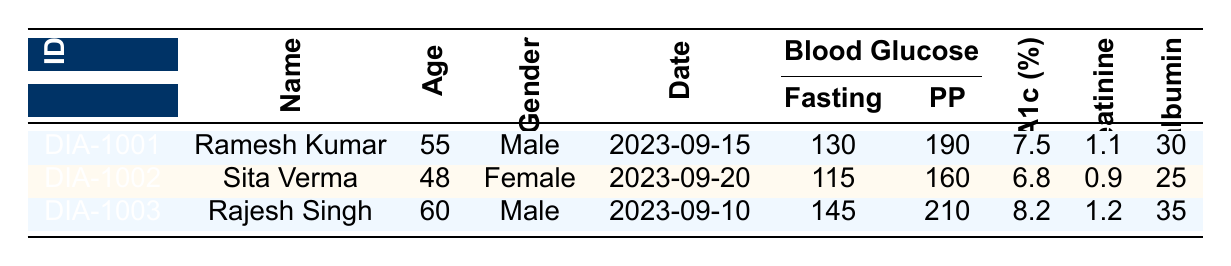What is the fasting blood glucose level for Sita Verma? In the table, Sita Verma's row shows her fasting blood glucose level listed under the "Blood Glucose" column in the fasting row, which is 115 mg/dL.
Answer: 115 mg/dL Which patient has the highest HbA1c percentage? By comparing the HbA1c percentages listed in the table, Rajesh Singh has the highest value of 8.2%, which is more than the others.
Answer: Rajesh Singh What is the total cholesterol level for Ramesh Kumar? Looking at Ramesh Kumar's data in the table, his total cholesterol level is noted as 220 mg/dL, directly taken from the cholesterol total column.
Answer: 220 mg/dL Is the urine microalbumin level for Rajesh Singh normal? The urine microalbumin level for Rajesh Singh is 35 mg/L. Generally, a level above 30 mg/L is considered abnormal for diabetic patients; thus, it is considered not normal.
Answer: No What is the average fasting blood glucose level of all patients? To find the average, we first sum the fasting blood glucose levels: 130 + 115 + 145 = 390 mg/dL. Then, we divide by the number of patients (3): 390/3 = 130 mg/dL.
Answer: 130 mg/dL How many female patients are listed in the table? In the table, there is only one female patient, Sita Verma. By observing the gender column across all entries, we can confirm this count.
Answer: 1 What is the difference in total cholesterol between Ramesh Kumar and Rajesh Singh? Ramesh Kumar’s total cholesterol is 220 mg/dL, and Rajesh Singh’s total cholesterol is 250 mg/dL. The difference is calculated as 250 - 220 = 30 mg/dL.
Answer: 30 mg/dL What percentage of patients have a triglyceride level above 200 mg/dL? In the table, only Rajesh Singh has a triglyceride level of 210 mg/dL, which is above 200 mg/dL; therefore, among 3 patients, the percentage is (1/3) * 100 = 33.33%.
Answer: 33.33% 